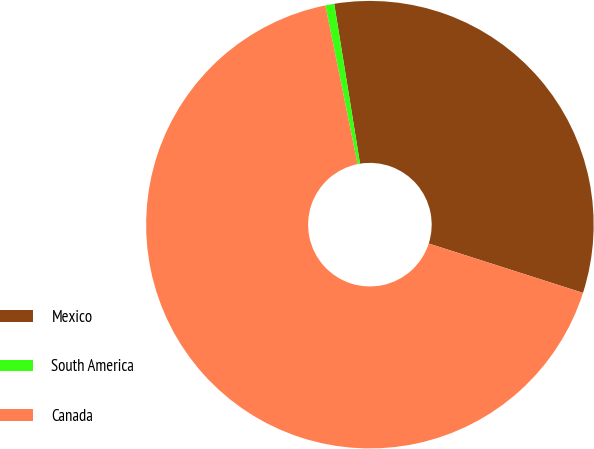Convert chart to OTSL. <chart><loc_0><loc_0><loc_500><loc_500><pie_chart><fcel>Mexico<fcel>South America<fcel>Canada<nl><fcel>32.48%<fcel>0.64%<fcel>66.88%<nl></chart> 